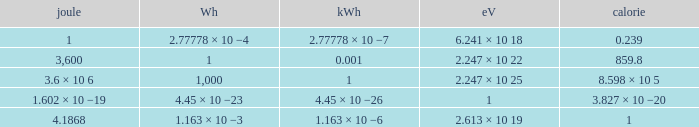How many calories is 1 watt hour? 859.8. 